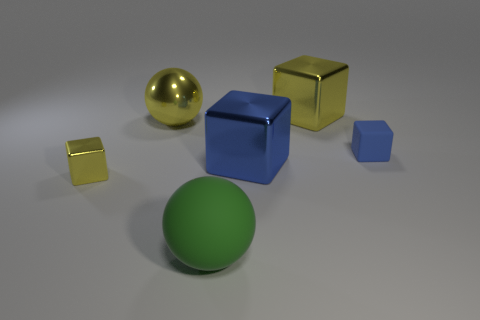Subtract all large blue shiny cubes. How many cubes are left? 3 Subtract 1 cubes. How many cubes are left? 3 Add 2 rubber objects. How many objects exist? 8 Subtract all brown blocks. Subtract all gray cylinders. How many blocks are left? 4 Subtract all spheres. How many objects are left? 4 Subtract all large matte cylinders. Subtract all big yellow shiny blocks. How many objects are left? 5 Add 2 large yellow metal objects. How many large yellow metal objects are left? 4 Add 2 tiny blue objects. How many tiny blue objects exist? 3 Subtract 0 purple blocks. How many objects are left? 6 